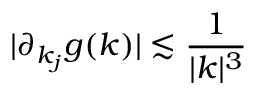Convert formula to latex. <formula><loc_0><loc_0><loc_500><loc_500>| \partial _ { k _ { j } } g ( k ) | \lesssim \frac { 1 } { | k | ^ { 3 } }</formula> 